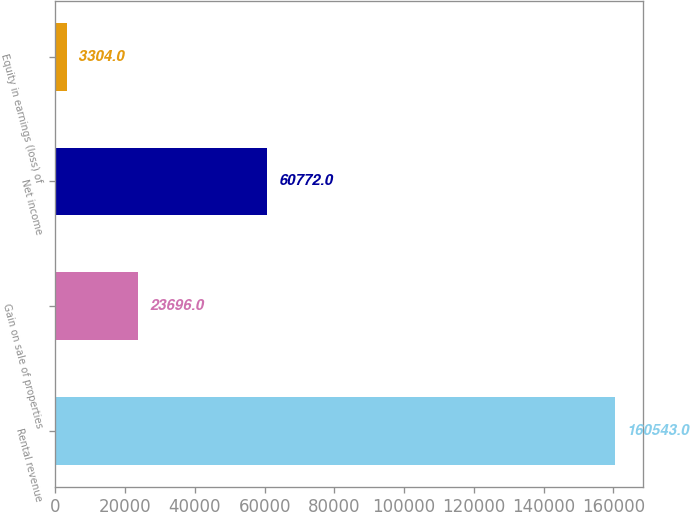<chart> <loc_0><loc_0><loc_500><loc_500><bar_chart><fcel>Rental revenue<fcel>Gain on sale of properties<fcel>Net income<fcel>Equity in earnings (loss) of<nl><fcel>160543<fcel>23696<fcel>60772<fcel>3304<nl></chart> 